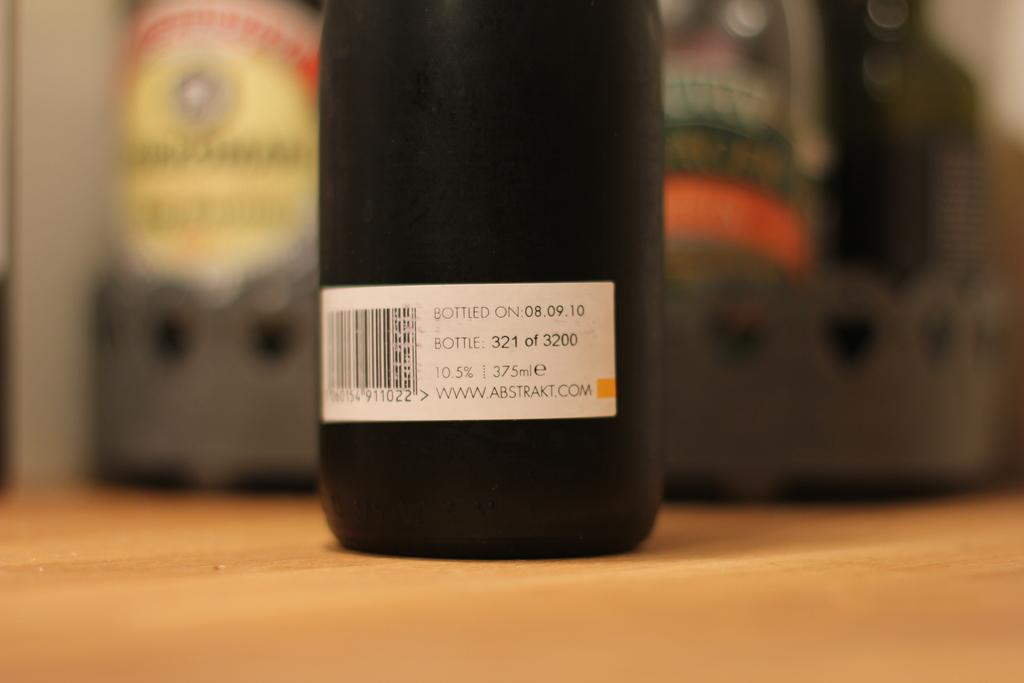What object is present in the image? There is a bottle in the image. Where is the bottle located? The bottle is on a wooden platform. Can you describe the background of the image? The background of the image is blurry. What type of cheese is visible on the ground in the image? There is no cheese present in the image, and the ground is not visible. Where is the hydrant located in the image? There is no hydrant present in the image. 